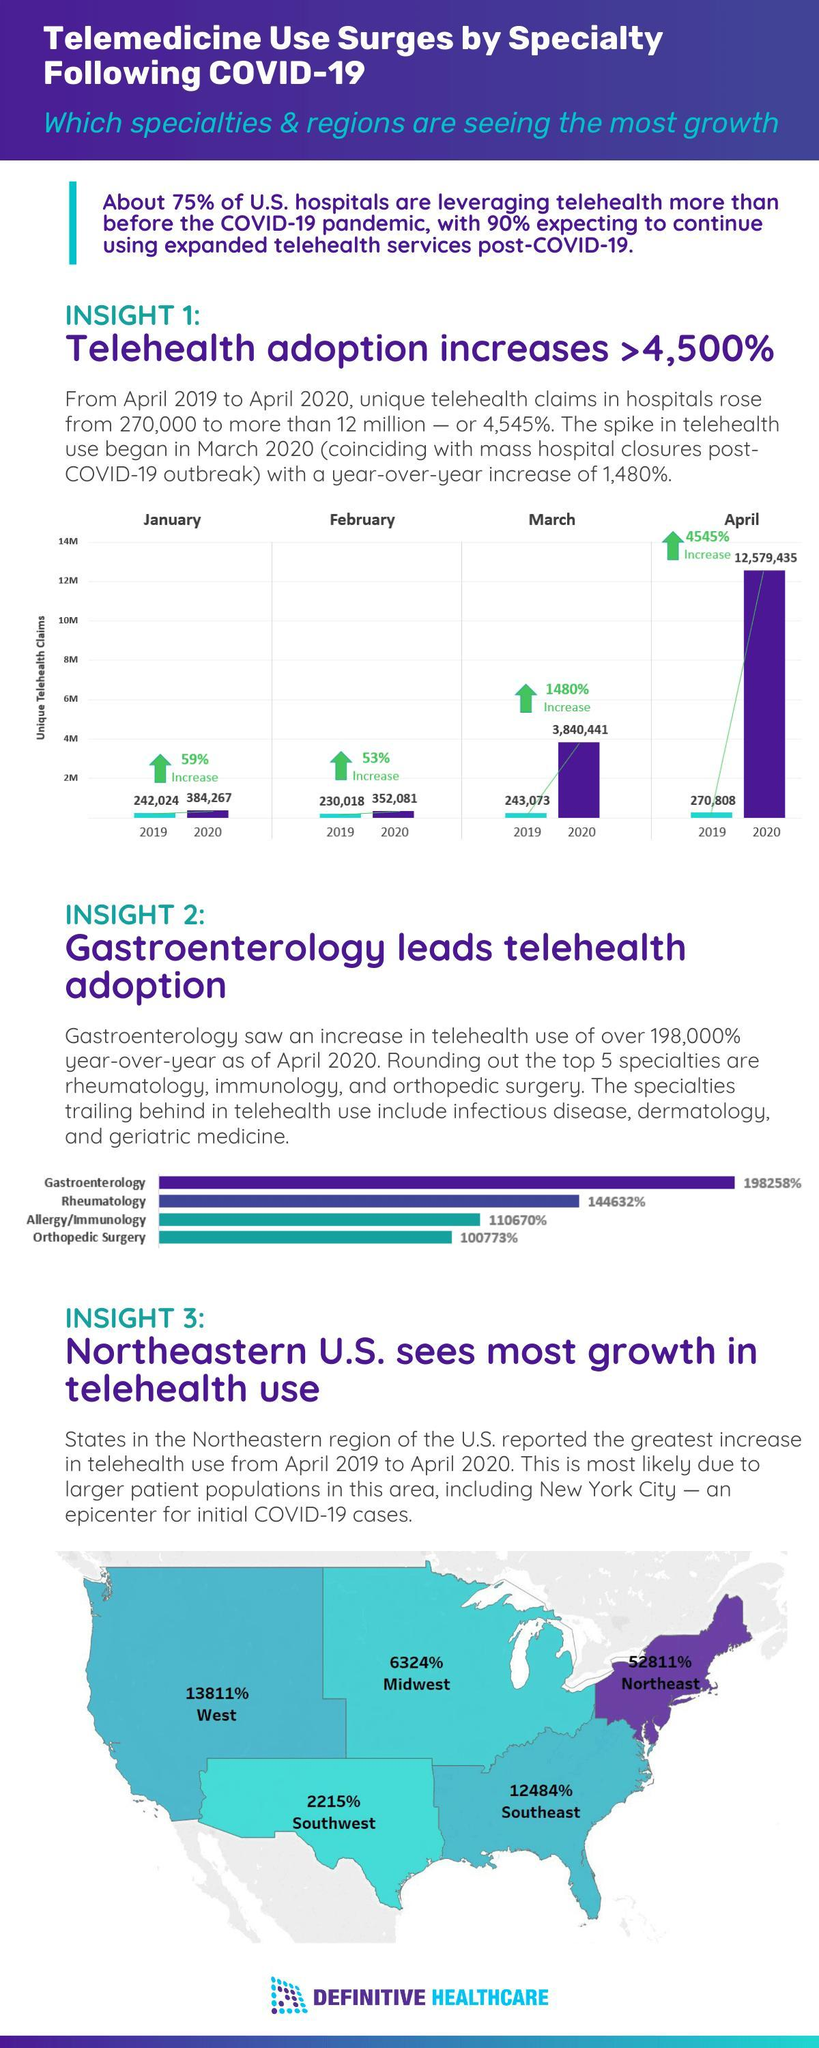What is the percent increase of telehealth use in the southeast region of the U.S. from April 2019 to April 2020?
Answer the question with a short phrase. 12484% What is the year-over-year growth rate of telehealth use in Rheumatology in the U.S. hospitals as of April 2020? 144632% What is the year-over-year growth rate of unique telehealth claims in the U.S. hospitals as of  January 2020? 59% What is the percent increase of telehealth use in the midwest region of the U.S. from April 2019 to April 2020? 6324% How many telehealth claims were reported in the U.S. hospitals in March 2020? 3,840,441 Which region of the U.S. reported the least increase in the telehealth use from April 2019 to April 2020? Southwest What is the year-over-year growth rate of unique telehealth claims in the U.S. hospitals as of April 2020? 4545% What is the year-over-year growth rate of unique telehealth claims in the U.S. hospitals as of February 2020? 53% How many telehealth claims were reported in the U.S. hospitals in April 2020? 12,579,435 